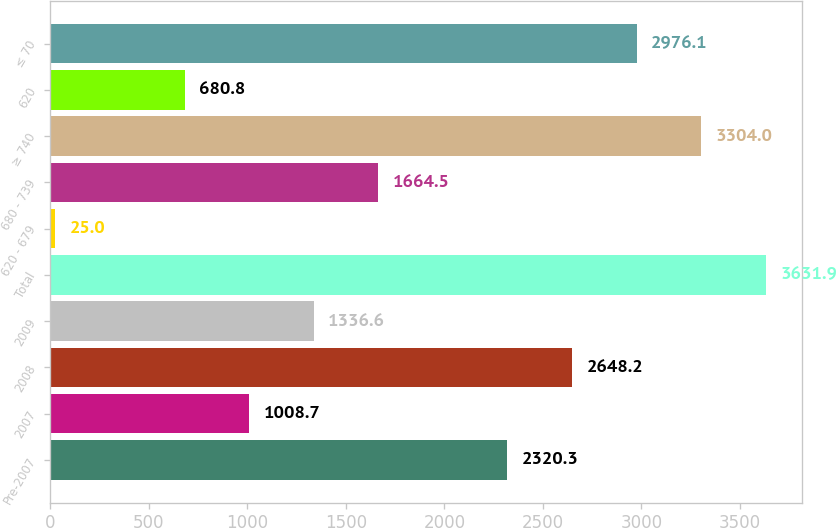Convert chart. <chart><loc_0><loc_0><loc_500><loc_500><bar_chart><fcel>Pre-2007<fcel>2007<fcel>2008<fcel>2009<fcel>Total<fcel>620 - 679<fcel>680 - 739<fcel>≥ 740<fcel>620<fcel>≤ 70<nl><fcel>2320.3<fcel>1008.7<fcel>2648.2<fcel>1336.6<fcel>3631.9<fcel>25<fcel>1664.5<fcel>3304<fcel>680.8<fcel>2976.1<nl></chart> 